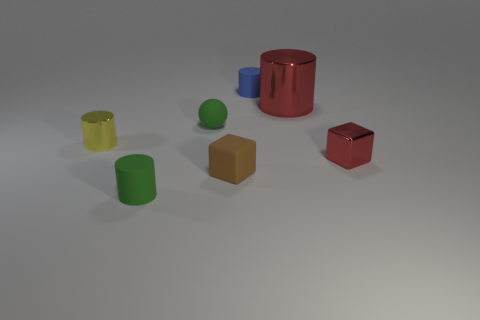What size is the metal object that is the same color as the large cylinder?
Offer a very short reply. Small. There is a tiny rubber object in front of the tiny block that is left of the tiny metallic object to the right of the tiny blue thing; what shape is it?
Your answer should be compact. Cylinder. Are there more rubber objects that are on the left side of the tiny blue object than big green matte cylinders?
Make the answer very short. Yes. There is a green rubber thing behind the green rubber cylinder; does it have the same shape as the small blue thing?
Offer a very short reply. No. There is a small cylinder behind the tiny ball; what is its material?
Your response must be concise. Rubber. How many blue matte things have the same shape as the large red shiny thing?
Your response must be concise. 1. What material is the cube that is in front of the cube that is to the right of the large metal thing?
Provide a succinct answer. Rubber. There is a thing that is the same color as the rubber sphere; what is its shape?
Give a very brief answer. Cylinder. Are there any other big gray objects made of the same material as the big thing?
Give a very brief answer. No. What is the shape of the tiny red metal thing?
Your answer should be very brief. Cube. 